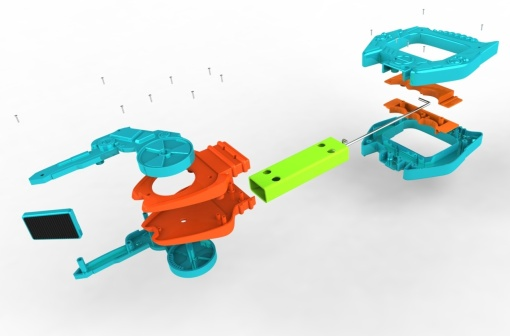What story might be unfolding in this image? This image seems to tell the story of a craftsman's careful work on assembling a toy car. Each component is methodically placed, revealing the craftsmanship involved in the process. The scattered screws and other parts suggest ongoing activity, perhaps someone joyfully working on piecing together this colorful toy, envisioning the joy it will bring once completed. Can you create a poetic description inspired by the image? In a realm of hues vibrant and bold,
Lies a tale of assembly, carefully told.
Sleek orange dreams meet green wheels of desire,
Crafted with precision, lined with sapphire.
Screws float mid-air, mid-work's pride,
A snapshot of effort, time-purified.
In chaos there's method, in pieces a plan,
The toy car’s journey, where joy began. 